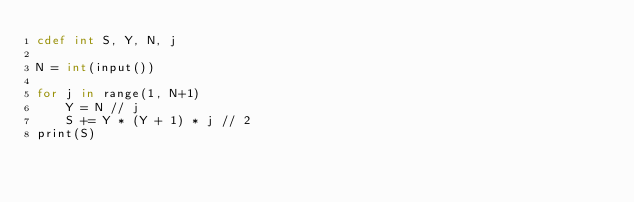<code> <loc_0><loc_0><loc_500><loc_500><_Cython_>cdef int S, Y, N, j

N = int(input())

for j in range(1, N+1)
    Y = N // j
    S += Y * (Y + 1) * j // 2
print(S)</code> 